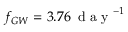<formula> <loc_0><loc_0><loc_500><loc_500>f _ { G W } = 3 . 7 6 \, d a y ^ { - 1 }</formula> 